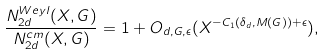<formula> <loc_0><loc_0><loc_500><loc_500>\frac { N _ { 2 d } ^ { W e y l } ( X , G ) } { N _ { 2 d } ^ { c m } ( X , G ) } = 1 + O _ { d , G , \epsilon } ( X ^ { - C _ { 1 } ( \delta _ { d } , M ( G ) ) + \epsilon } ) ,</formula> 